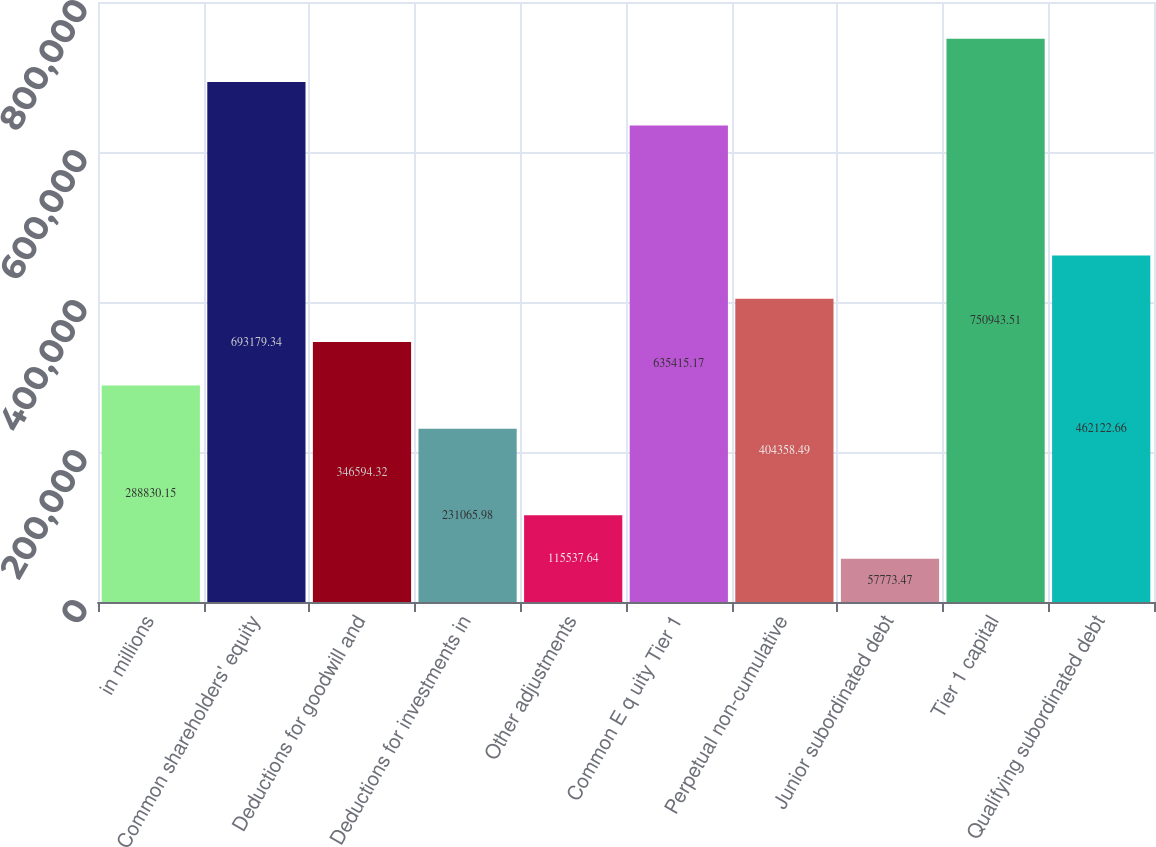<chart> <loc_0><loc_0><loc_500><loc_500><bar_chart><fcel>in millions<fcel>Common shareholders' equity<fcel>Deductions for goodwill and<fcel>Deductions for investments in<fcel>Other adjustments<fcel>Common E q uity Tier 1<fcel>Perpetual non-cumulative<fcel>Junior subordinated debt<fcel>Tier 1 capital<fcel>Qualifying subordinated debt<nl><fcel>288830<fcel>693179<fcel>346594<fcel>231066<fcel>115538<fcel>635415<fcel>404358<fcel>57773.5<fcel>750944<fcel>462123<nl></chart> 